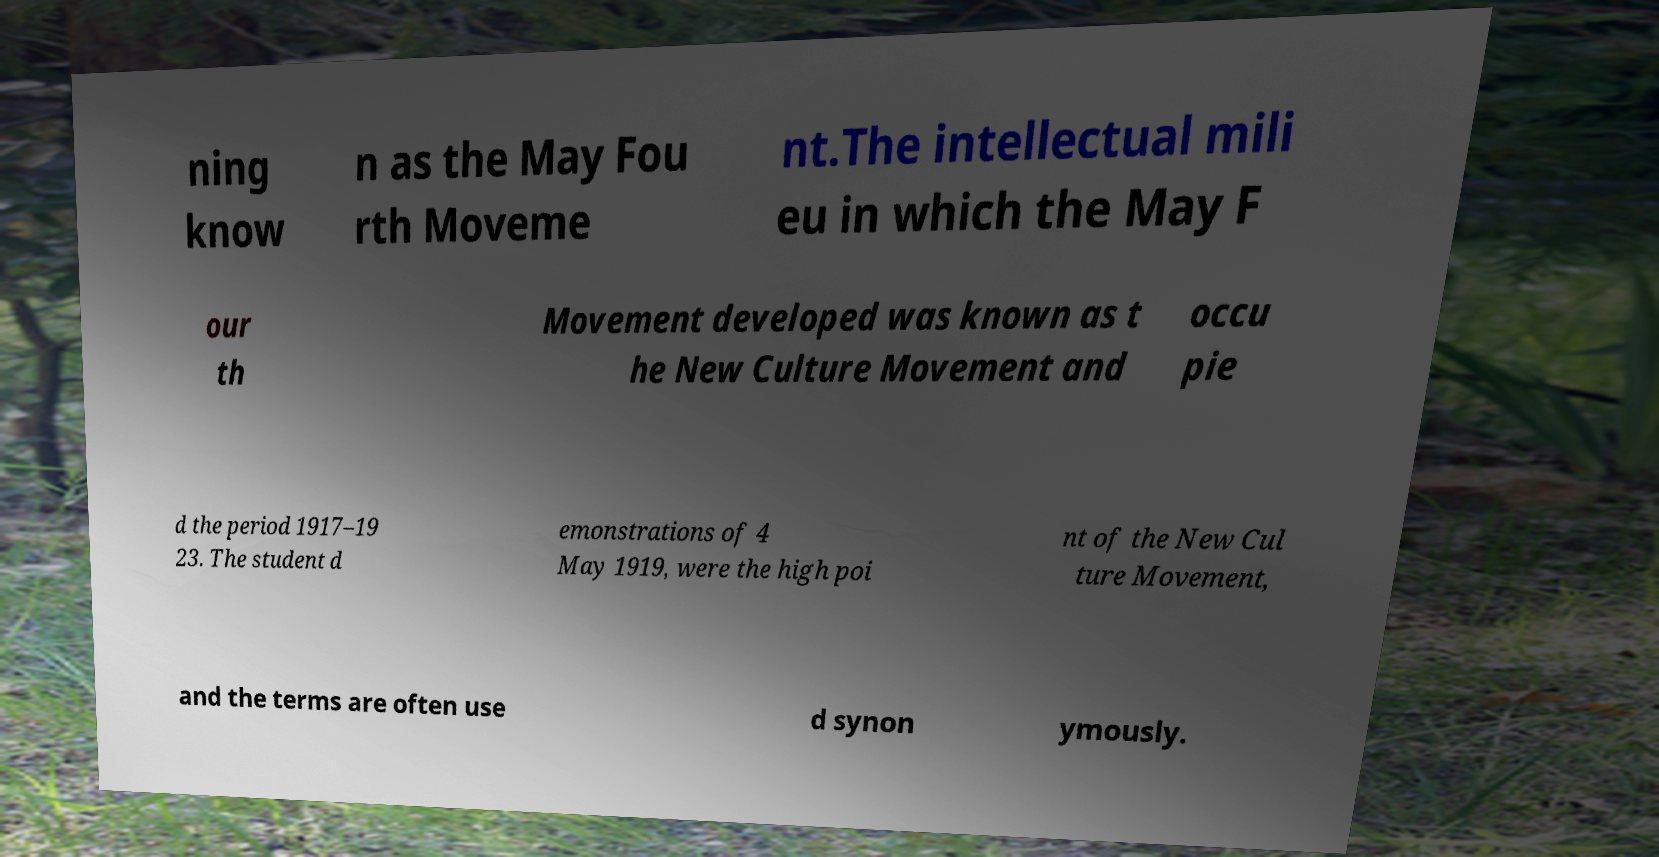Can you accurately transcribe the text from the provided image for me? ning know n as the May Fou rth Moveme nt.The intellectual mili eu in which the May F our th Movement developed was known as t he New Culture Movement and occu pie d the period 1917–19 23. The student d emonstrations of 4 May 1919, were the high poi nt of the New Cul ture Movement, and the terms are often use d synon ymously. 